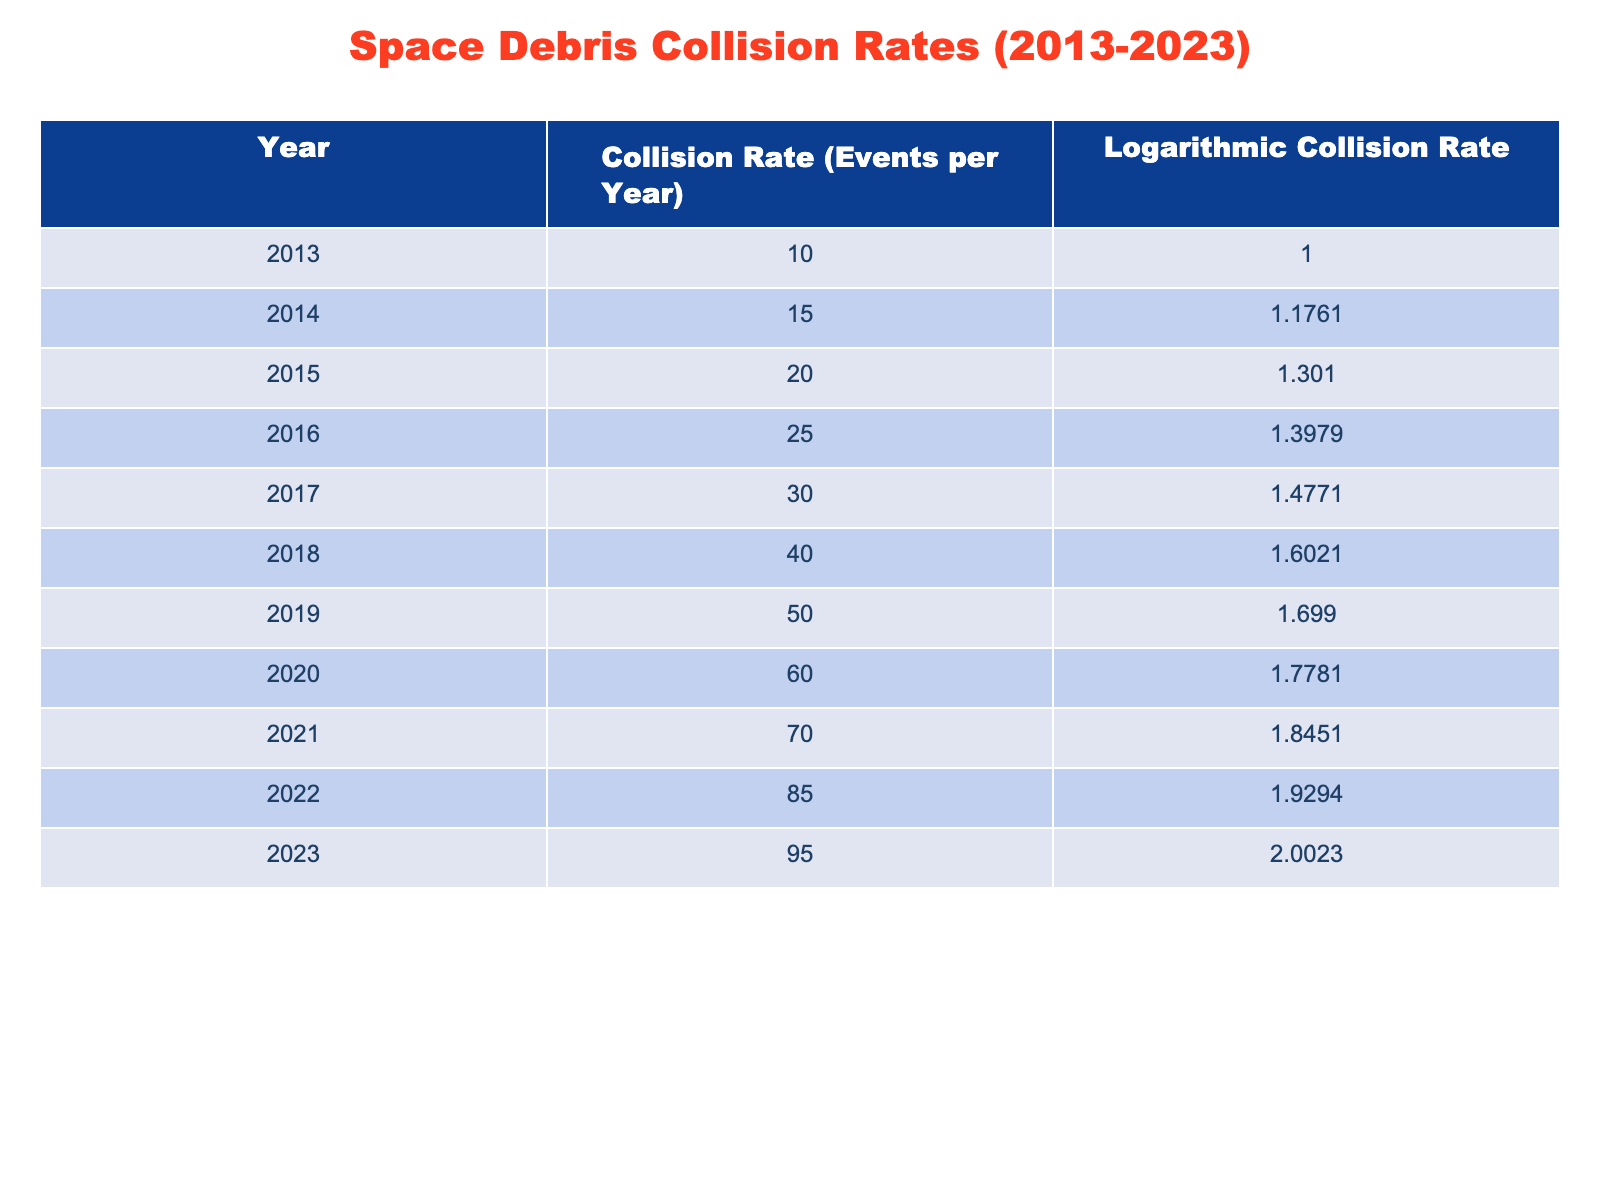What was the collision rate in 2020? The table shows the values for each year. For 2020, the collision rate is listed under the "Collision Rate (Events per Year)" column, which is 60.
Answer: 60 What was the logarithmic collision rate in 2015? The logarithmic collision rate for 2015 can be found directly in the table. It is listed as 1.3010 under the "Logarithmic Collision Rate" column.
Answer: 1.3010 What is the difference between the collision rates in 2023 and 2017? To find the difference, we look at the collision rates for each year. In 2023, the rate is 95, and in 2017, it is 30. The difference is 95 - 30 = 65.
Answer: 65 Did the collision rate ever drop from the previous year? By examining the table, we can see that the collision rate consistently increased each year from 2013 to 2023 without any drops. Therefore, the answer is no.
Answer: No What was the average collision rate over the past decade (2013-2023)? First, we add up the collision rates from all years: 10 + 15 + 20 + 25 + 30 + 40 + 50 + 60 + 70 + 85 + 95 =  60. The total number of years is 11. So, the average is 605 / 11 = 55.
Answer: 55 In which year did the collision rate exceed 80 events? We analyze the table, where the collision rates are listed for each year. The only year where the collision rate exceeded 80 events is 2022 (85) and 2023 (95).
Answer: 2022 and 2023 How much did the logarithmic collision rate increase from 2016 to 2020? We take the logarithmic collision rates for both years: in 2016 it is 1.3979 and in 2020 it is 1.7781. The increase is calculated as 1.7781 - 1.3979 = 0.3802.
Answer: 0.3802 Which year had the highest collision rate and what was it? By checking the table, we see that the collision rate peaked in 2023 at 95 events. Therefore, 2023 had the highest collision rate.
Answer: 2023, 95 What year saw a collision rate of exactly 50 events? Looking at the table, we find that the collision rate reached exactly 50 events in the year 2019, as listed in the data.
Answer: 2019 